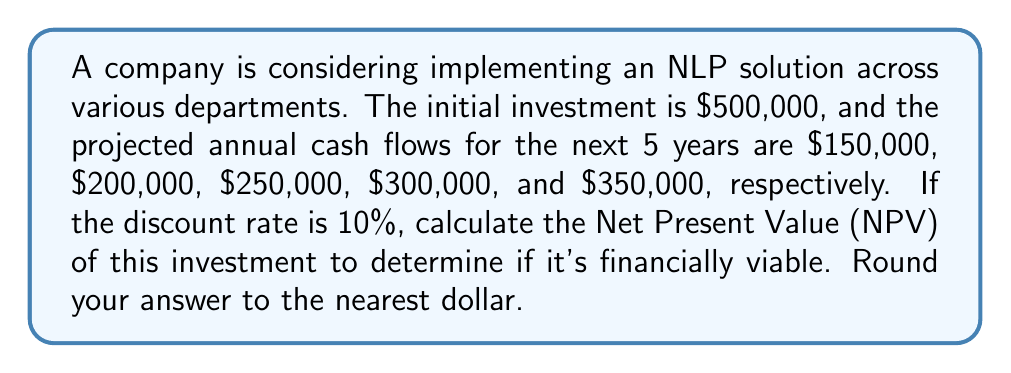Provide a solution to this math problem. To calculate the Net Present Value (NPV), we need to follow these steps:

1. Calculate the present value of each future cash flow:
   PV = CF / (1 + r)^t, where CF is cash flow, r is discount rate, and t is time period

2. Sum all present values of future cash flows

3. Subtract the initial investment from the sum of present values

Let's calculate:

1. Present values for each year:
   Year 1: $\frac{150000}{(1 + 0.1)^1} = \frac{150000}{1.1} = 136363.64$
   Year 2: $\frac{200000}{(1 + 0.1)^2} = \frac{200000}{1.21} = 165289.26$
   Year 3: $\frac{250000}{(1 + 0.1)^3} = \frac{250000}{1.331} = 187828.70$
   Year 4: $\frac{300000}{(1 + 0.1)^4} = \frac{300000}{1.4641} = 204904.72$
   Year 5: $\frac{350000}{(1 + 0.1)^5} = \frac{350000}{1.61051} = 217321.96$

2. Sum of present values:
   $136363.64 + 165289.26 + 187828.70 + 204904.72 + 217321.96 = 911708.28$

3. NPV calculation:
   NPV = Sum of present values - Initial investment
   $NPV = 911708.28 - 500000 = 411708.28$

Rounding to the nearest dollar: $411,708

Since the NPV is positive, the investment is financially viable.
Answer: $411,708 